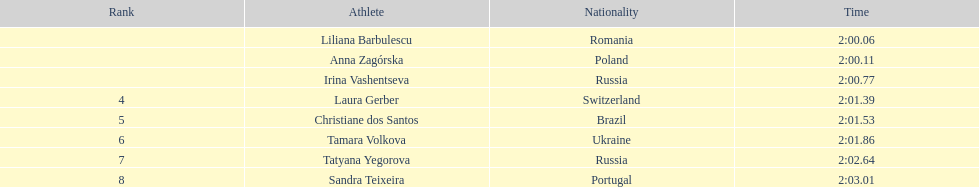From which country did the most top 8 finishers originate? Russia. 